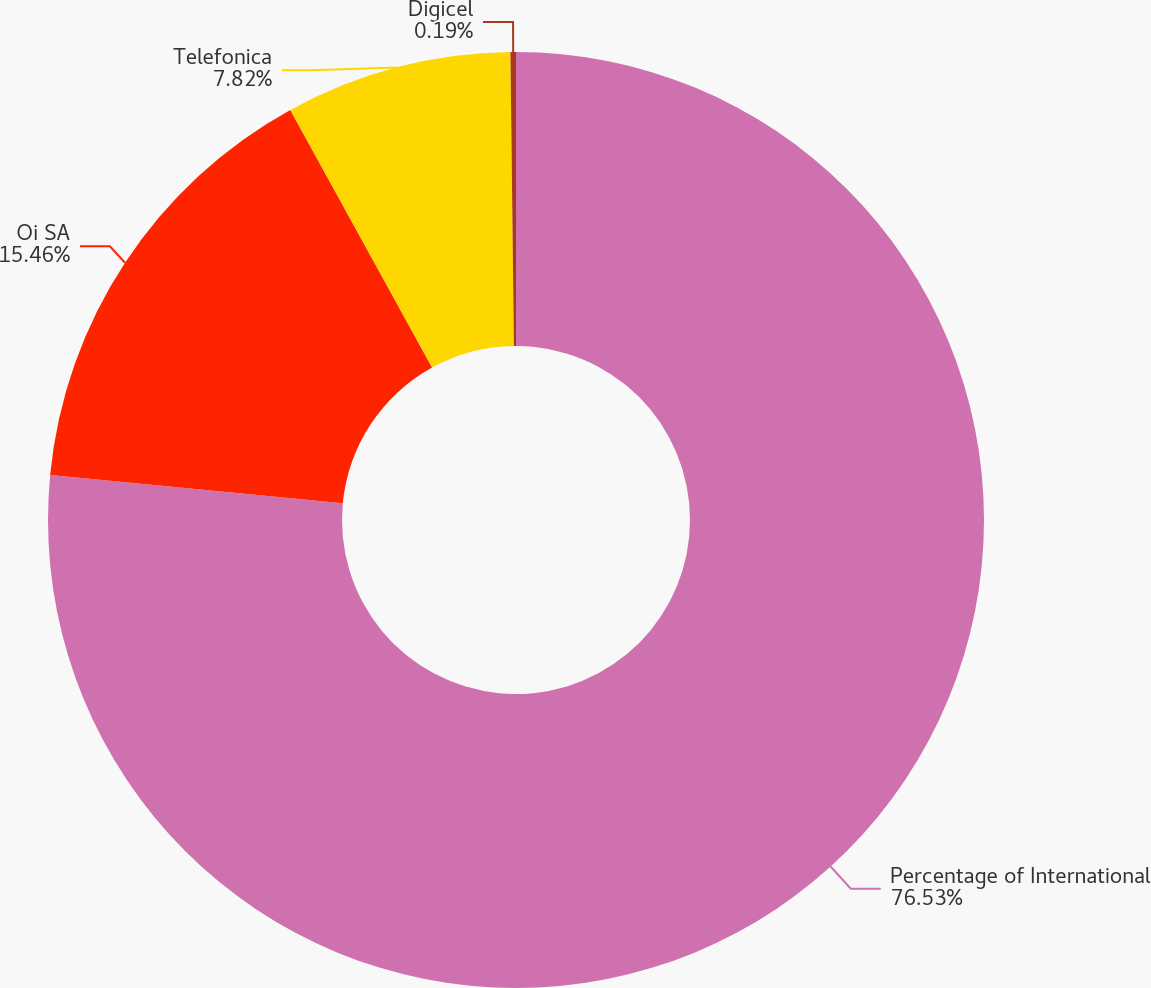Convert chart to OTSL. <chart><loc_0><loc_0><loc_500><loc_500><pie_chart><fcel>Percentage of International<fcel>Oi SA<fcel>Telefonica<fcel>Digicel<nl><fcel>76.54%<fcel>15.46%<fcel>7.82%<fcel>0.19%<nl></chart> 